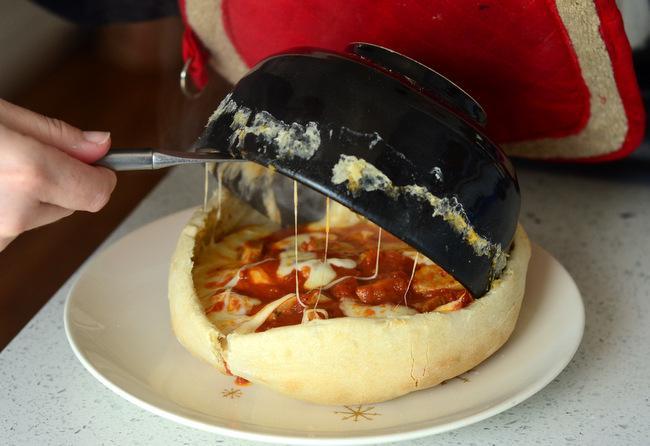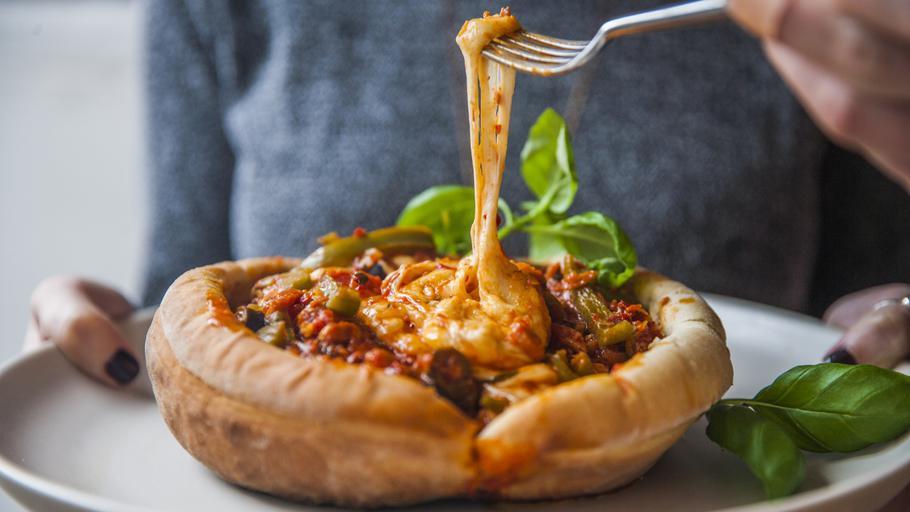The first image is the image on the left, the second image is the image on the right. Considering the images on both sides, is "There is a pizza pot pie in the center of each image." valid? Answer yes or no. Yes. The first image is the image on the left, the second image is the image on the right. Given the left and right images, does the statement "One image shows a fork above a single-serve round pizza with a rolled crust edge, and cheese is stretching from the fork to the pizza." hold true? Answer yes or no. Yes. 